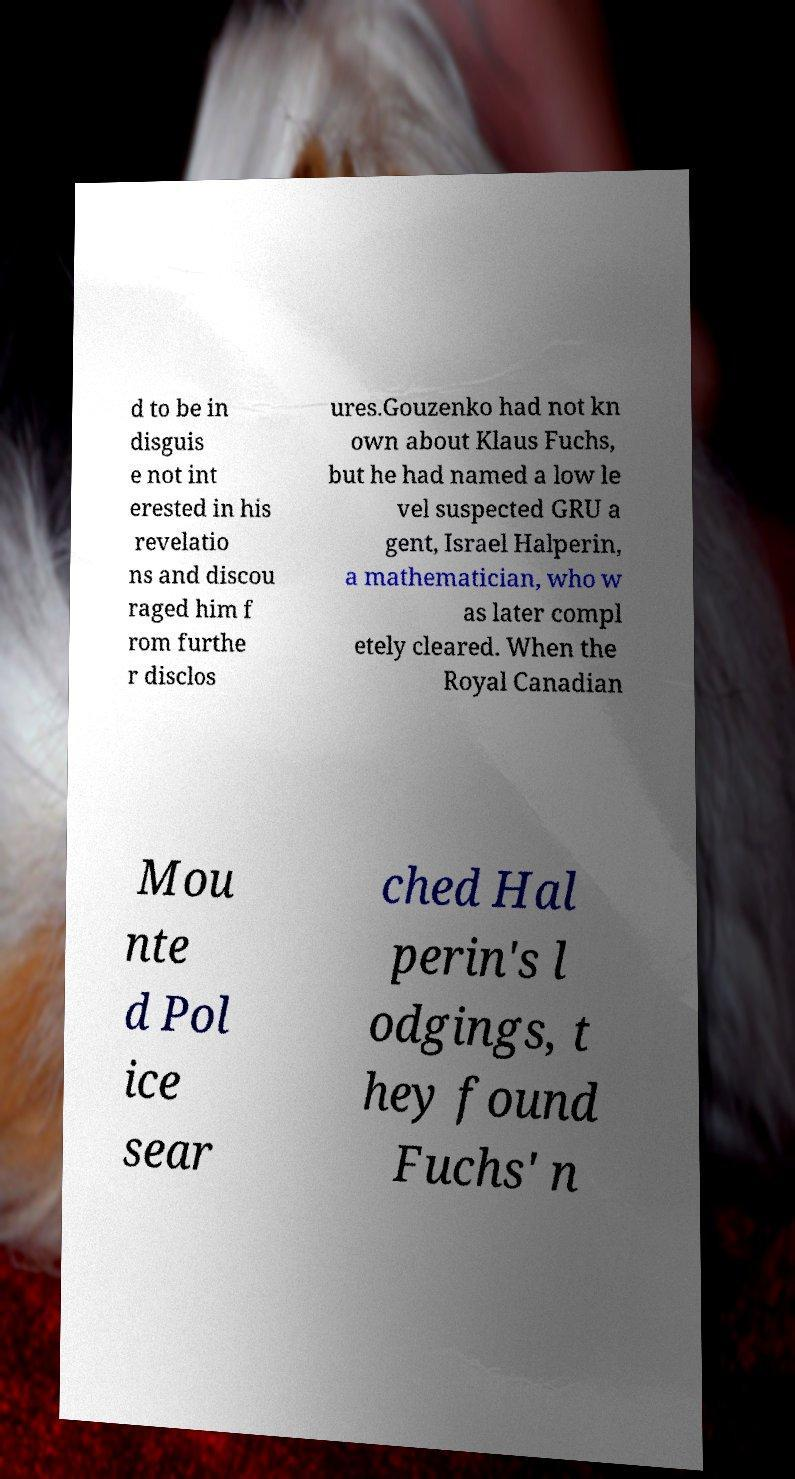Can you accurately transcribe the text from the provided image for me? d to be in disguis e not int erested in his revelatio ns and discou raged him f rom furthe r disclos ures.Gouzenko had not kn own about Klaus Fuchs, but he had named a low le vel suspected GRU a gent, Israel Halperin, a mathematician, who w as later compl etely cleared. When the Royal Canadian Mou nte d Pol ice sear ched Hal perin's l odgings, t hey found Fuchs' n 